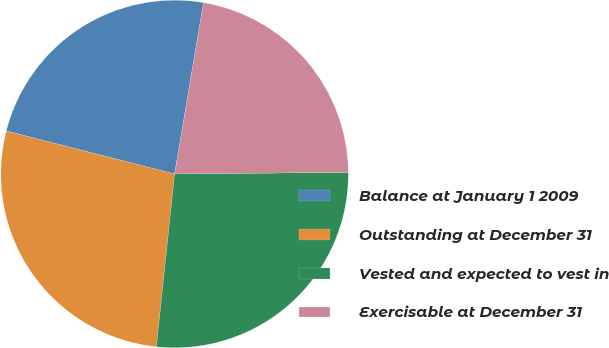<chart> <loc_0><loc_0><loc_500><loc_500><pie_chart><fcel>Balance at January 1 2009<fcel>Outstanding at December 31<fcel>Vested and expected to vest in<fcel>Exercisable at December 31<nl><fcel>23.68%<fcel>27.31%<fcel>26.82%<fcel>22.19%<nl></chart> 